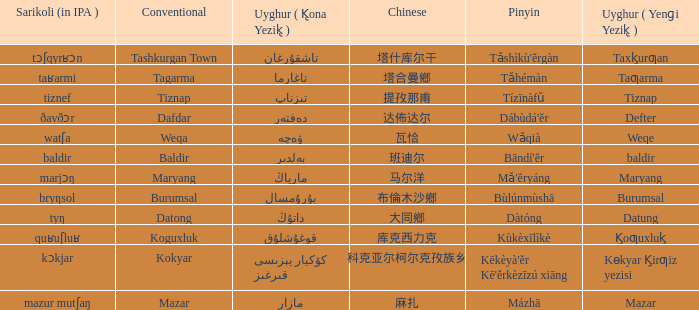Name the pinyin for mazar Mázhā. 